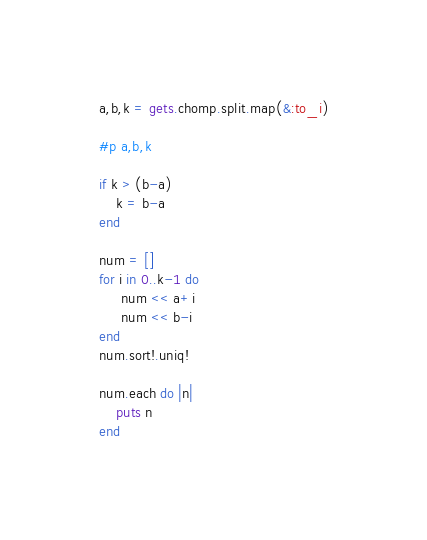<code> <loc_0><loc_0><loc_500><loc_500><_Ruby_>a,b,k = gets.chomp.split.map(&:to_i)

#p a,b,k

if k > (b-a)
    k = b-a
end

num = []
for i in 0..k-1 do
     num << a+i
     num << b-i
end
num.sort!.uniq!

num.each do |n|
    puts n
end</code> 